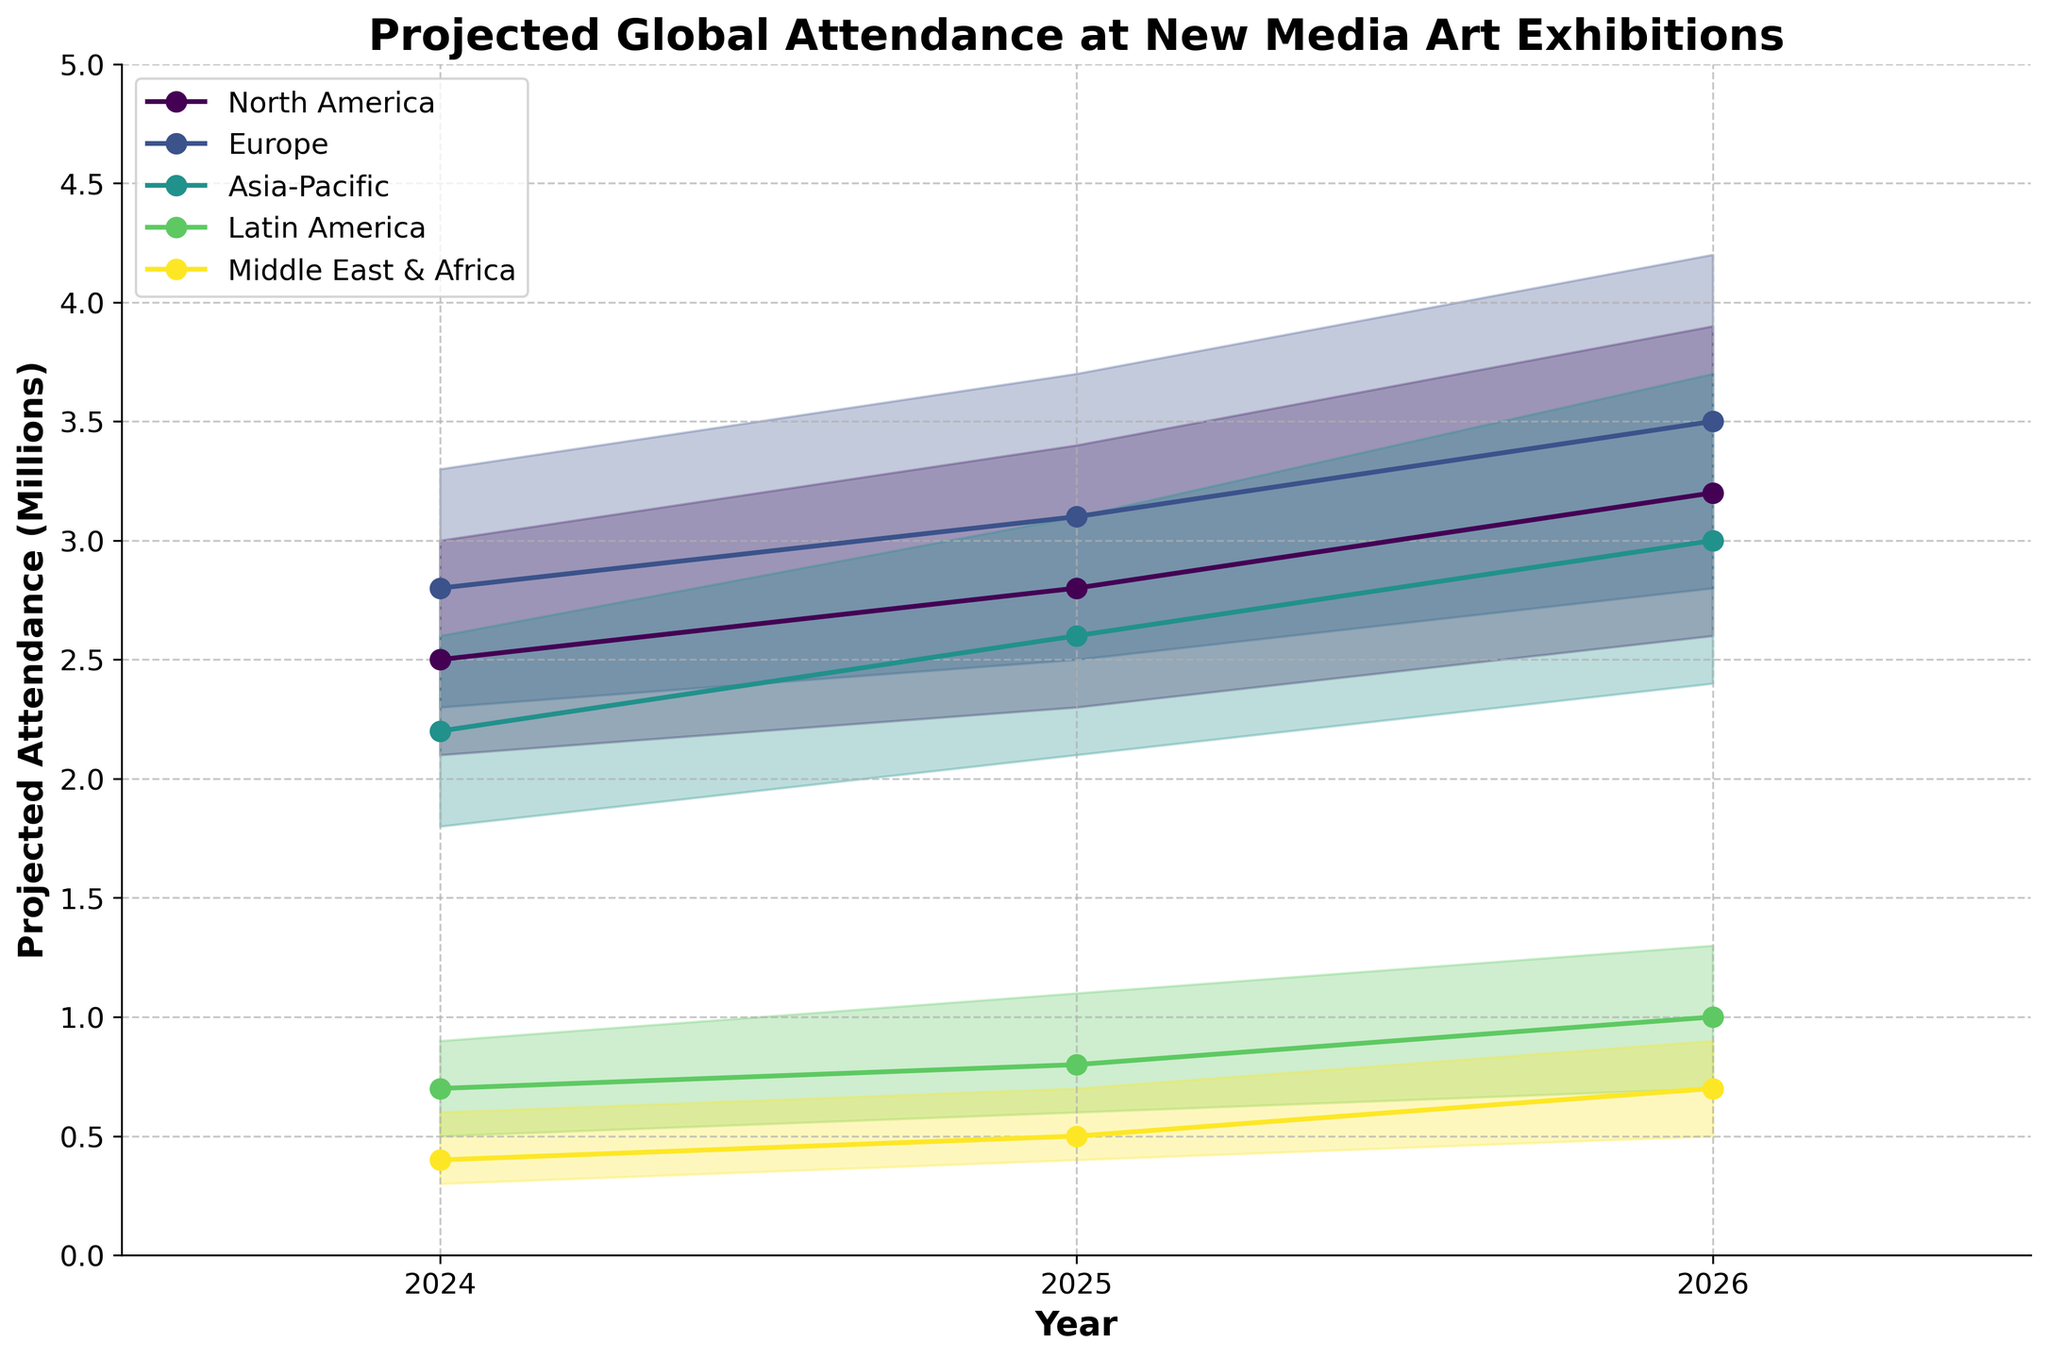What is the title of the figure? The title of the figure is the text that appears at the top of the graph to provide context about what the figure represents. In this case, it indicates the subject being visualized.
Answer: Projected Global Attendance at New Media Art Exhibitions What is the projected median attendance for North America in 2026? To find the projected median attendance for North America in 2026, refer to the median value on the plot for North America in the year 2026.
Answer: 3.2 million Which region has the highest projected median attendance in 2025? To determine which region has the highest projected median attendance in 2025, look for the highest median value among the regions plotted for that year.
Answer: Europe How does the median projected attendance for Asia-Pacific change from 2024 to 2026? To observe how the median projected attendance for Asia-Pacific changes from 2024 to 2026, compare the median values plotted for Asia-Pacific over these years.
Answer: Increases from 2.2 million to 3.0 million What is the range of projected attendance for Latin America in 2024? The range of projected attendance can be found by subtracting the low value from the high value for Latin America in 2024.
Answer: 0.4 million Which region shows the smallest variation in projected attendance in 2026? To determine the region with the smallest variation in projected attendance in 2026, compare the difference between the high and low values for each region in that year.
Answer: Middle East & Africa Between which years does North America show the largest increase in median projected attendance? To find the period where North America shows the largest increase in median projected attendance, compute the differences in median values between consecutive years and identify the greatest increase.
Answer: 2025 to 2026 What is the projected median attendance for Europe in 2026 compared to 2024? To compare the projected median attendance for Europe in 2026 to 2024, subtract the median value in 2024 from the median value in 2026 for Europe.
Answer: 0.7 million increase Which region has the lowest high projected attendance across all years? To identify the region with the lowest high projected attendance, compare the high values across all years for each region and find the minimum.
Answer: Middle East & Africa 